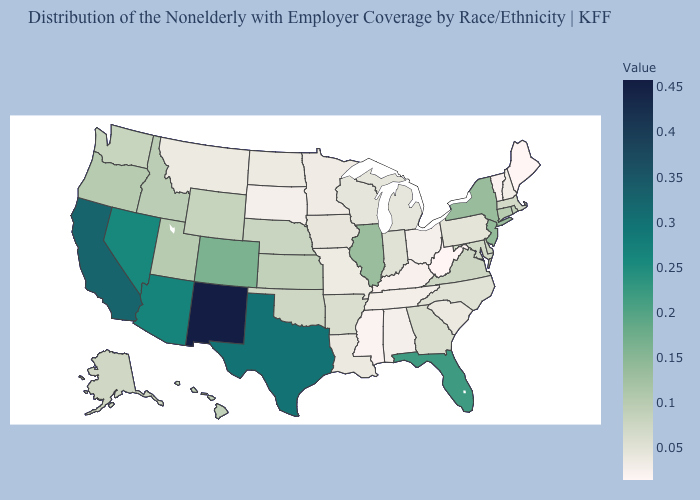Among the states that border Illinois , does Indiana have the highest value?
Answer briefly. Yes. Does New Mexico have the highest value in the USA?
Quick response, please. Yes. Among the states that border Maryland , which have the lowest value?
Concise answer only. West Virginia. Is the legend a continuous bar?
Be succinct. Yes. Does the map have missing data?
Quick response, please. No. Which states have the highest value in the USA?
Answer briefly. New Mexico. 